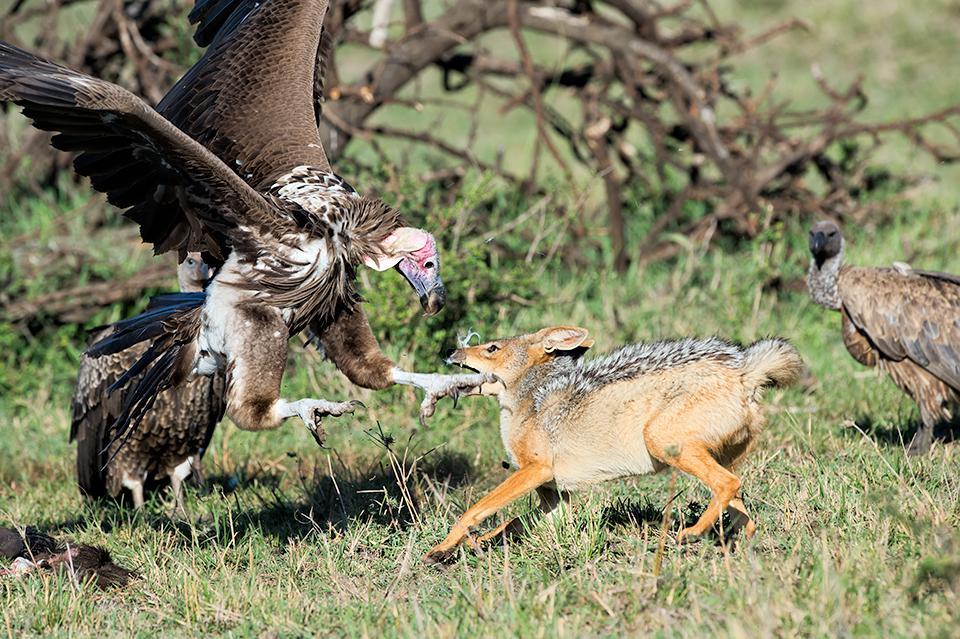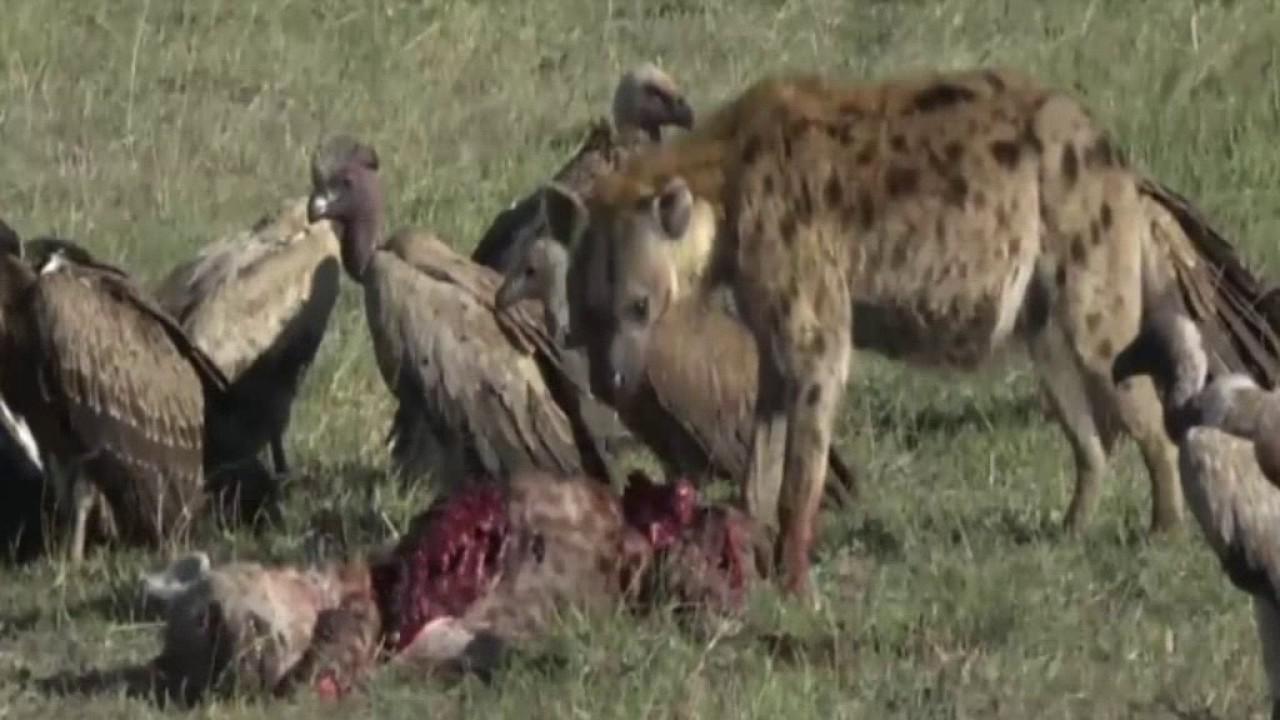The first image is the image on the left, the second image is the image on the right. Analyze the images presented: Is the assertion "There are two cheetahs eat pry as a wall of at least 10 vulture wait to get the leftovers." valid? Answer yes or no. No. The first image is the image on the left, the second image is the image on the right. Given the left and right images, does the statement "At least one vulture is in the air." hold true? Answer yes or no. Yes. 